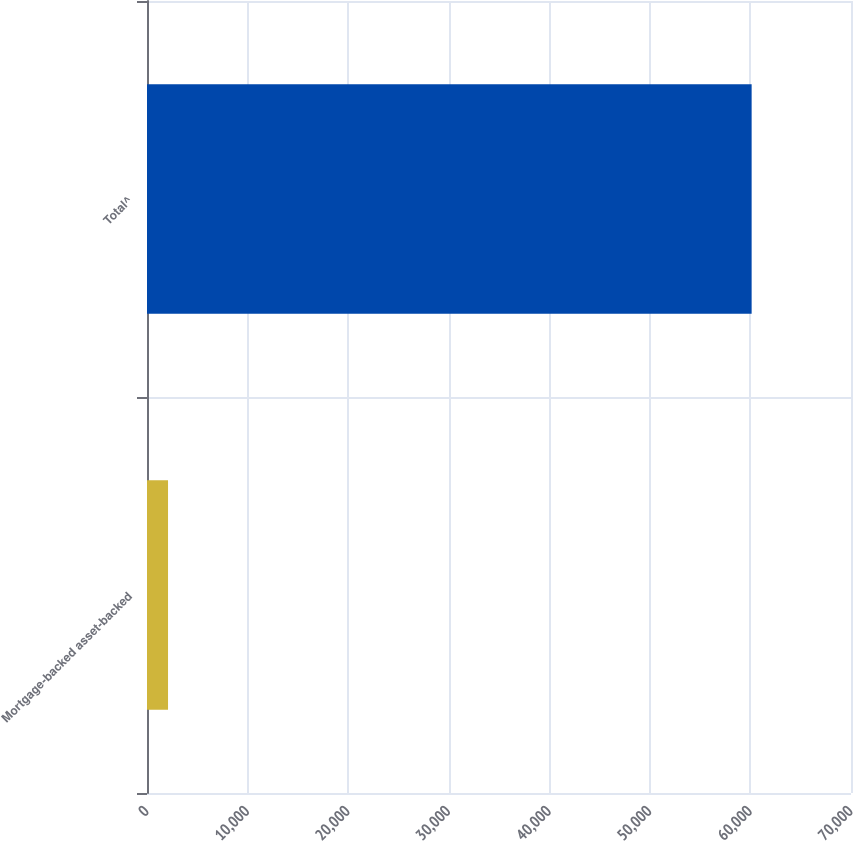<chart> <loc_0><loc_0><loc_500><loc_500><bar_chart><fcel>Mortgage-backed asset-backed<fcel>Total^<nl><fcel>2091<fcel>60120<nl></chart> 